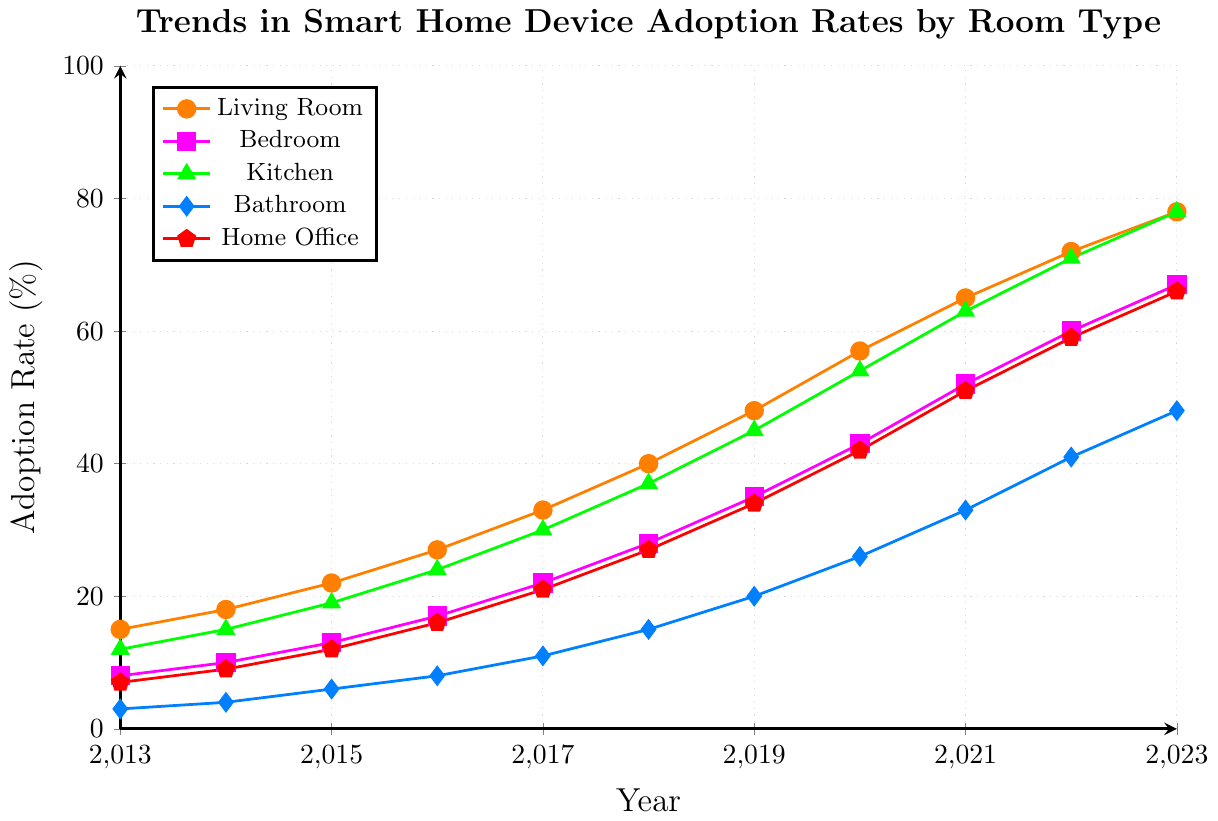What was the adoption rate for smart home devices in the Living Room and Kitchen in 2015? Referring to the figure, the adoption rate for the Living Room in 2015 was 22%, and for the Kitchen, it was 19%.
Answer: Living Room: 22%, Kitchen: 19% How much did the adoption rate for smart home devices in the Bathroom increase between 2013 and 2023? The adoption rate in 2013 was 3% and increased to 48% in 2023. The increase is 48% - 3% = 45%.
Answer: 45% Which room had the highest adoption rate of smart home devices in 2023? In 2023, the Kitchen and Living Room both had the highest adoption rate of 78%.
Answer: Kitchen and Living Room What is the average adoption rate of smart home devices in the Home Office over the decade 2013-2023? Sum the adoption rates for each year from 2013 to 2023 for the Home Office (7+9+12+16+21+27+34+42+51+59+66) which equals 344, then divide by 11 years: 344/11 = 31.27%.
Answer: 31.27% By how much did the adoption rate for smart home devices in the Bedroom increase from 2016 to 2021? The adoption rate for the Bedroom was 17% in 2016 and increased to 52% in 2021. The increase is 52% - 17% = 35%.
Answer: 35% In which year did the Kitchen surpass a 50% adoption rate for smart home devices? Referring to the figure, the Kitchen adoption rate surpassed 50% in 2020 when it reached 54%.
Answer: 2020 Calculate the difference in adoption rates between the Living Room and Bathroom in 2023. The adoption rate in 2023 for the Living Room was 78%, and for the Bathroom, it was 48%. The difference is 78% - 48% = 30%.
Answer: 30% Compare the trends in smart home device adoption rates between the Living Room and Bedroom from 2013 to 2023. Both the Living Room and Bedroom show an increasing trend, but the Living Room's adoption rates are consistently higher each year. In 2023, the Living Room rate is 78%, while the Bedroom is 67%.
Answer: Living Room consistently higher What is the combined adoption rate of smart home devices for the Kitchen, Bathroom, and Home Office in 2019? Summing up the adoption rates for 2019: Kitchen (45%) + Bathroom (20%) + Home Office (34%) = 45% + 20% + 34% = 99%.
Answer: 99% How many years did it take for the Bedroom's smart home device adoption rate to reach at least 60%? The Bedroom’s rate reached 60% in 2022. Starting from 2013, it took 2022 - 2013 = 9 years.
Answer: 9 years 